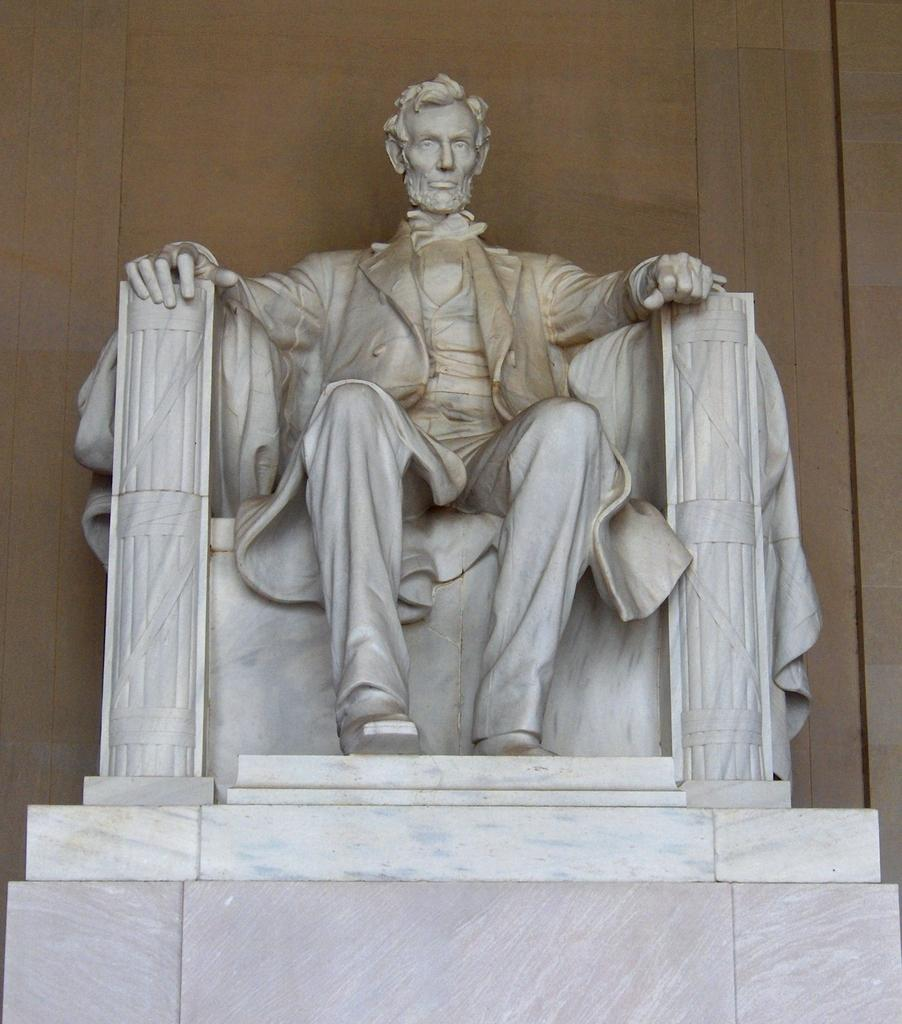What is the main subject of the image? The main subject of the image is a statue of a man. How is the man depicted in the statue? The statue depicts the man sitting on a chair. What can be seen in the background of the image? There is a wall in the background of the image. What type of mint plant is growing on the chair in the image? There is no mint plant present in the image; the statue depicts a man sitting on a chair. What degree does the man in the statue hold? The image is a statue and does not provide information about the man's educational qualifications. --- Facts: 1. There is a car in the image. 2. The car is parked on the street. 3. There are trees on both sides of the street. 4. The sky is visible in the image. Absurd Topics: parrot, sand, volleyball Conversation: What is the main subject of the image? The main subject of the image is a car. Where is the car located in the image? The car is parked on the street. What can be seen on both sides of the street in the image? There are trees on both sides of the street. What is visible at the top of the image? The sky is visible in the image. Reasoning: Let's think step by step in order to produce the conversation. We start by identifying the main subject of the image, which is the car. Then, we describe the specific location of the car, which is parked on the street. Next, we mention the presence of trees on both sides of the street. Finally, we acknowledge the presence of the sky at the top of the image. Absurd Question/Answer: Can you tell me how many parrots are sitting on the car in the image? There are no parrots present in the image; it features a car parked on the street with trees on both sides. What type of sand can be seen on the street in the image? There is no sand present on the street in the image; it is a paved street with a car parked on it. --- Facts: 1. There is a person holding a camera in the image. 2. The person is standing on a bridge. 3. There is a river visible below the bridge. 4. The sky is visible in the image. Absurd Topics: elephant, sandcastle, surfboard Conversation: What is the person in the image doing? The person in the image is holding a camera. Where is the person standing in the image? The person is standing on a bridge. What can be seen below the bridge in the image? There is a river visible below the bridge. What is visible at the top of the image? The sky is visible in the image. Reasoning: Let's think step by step in order to produce the 